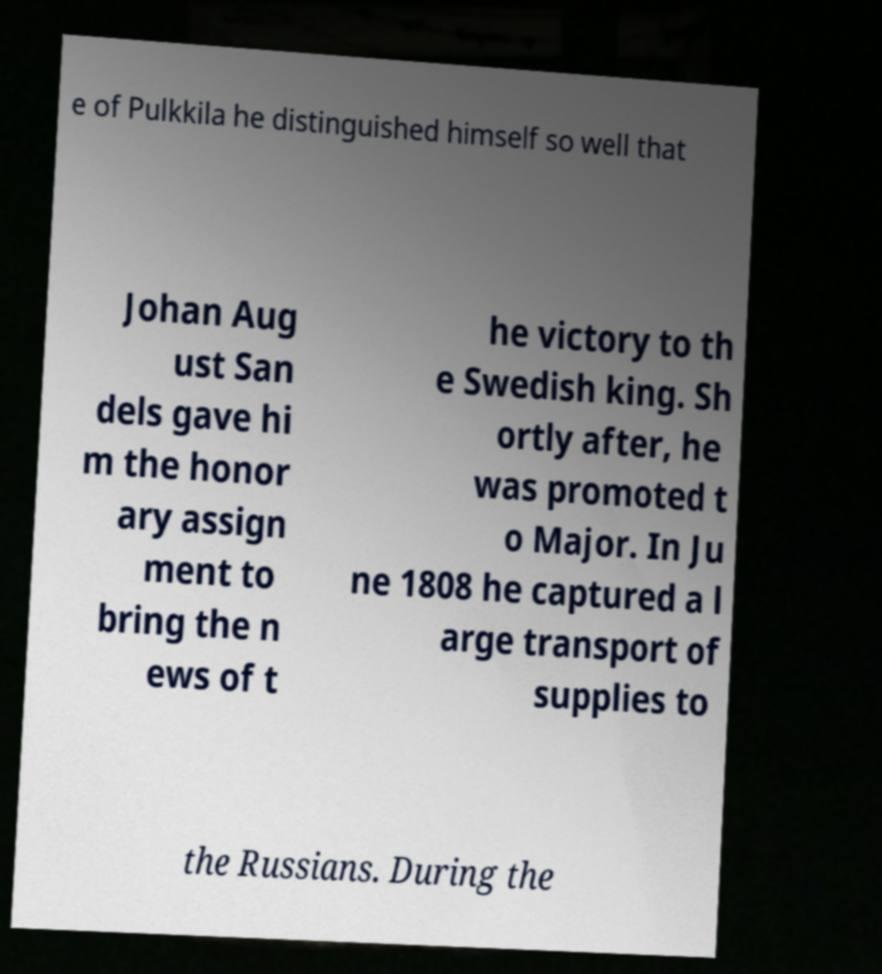There's text embedded in this image that I need extracted. Can you transcribe it verbatim? e of Pulkkila he distinguished himself so well that Johan Aug ust San dels gave hi m the honor ary assign ment to bring the n ews of t he victory to th e Swedish king. Sh ortly after, he was promoted t o Major. In Ju ne 1808 he captured a l arge transport of supplies to the Russians. During the 